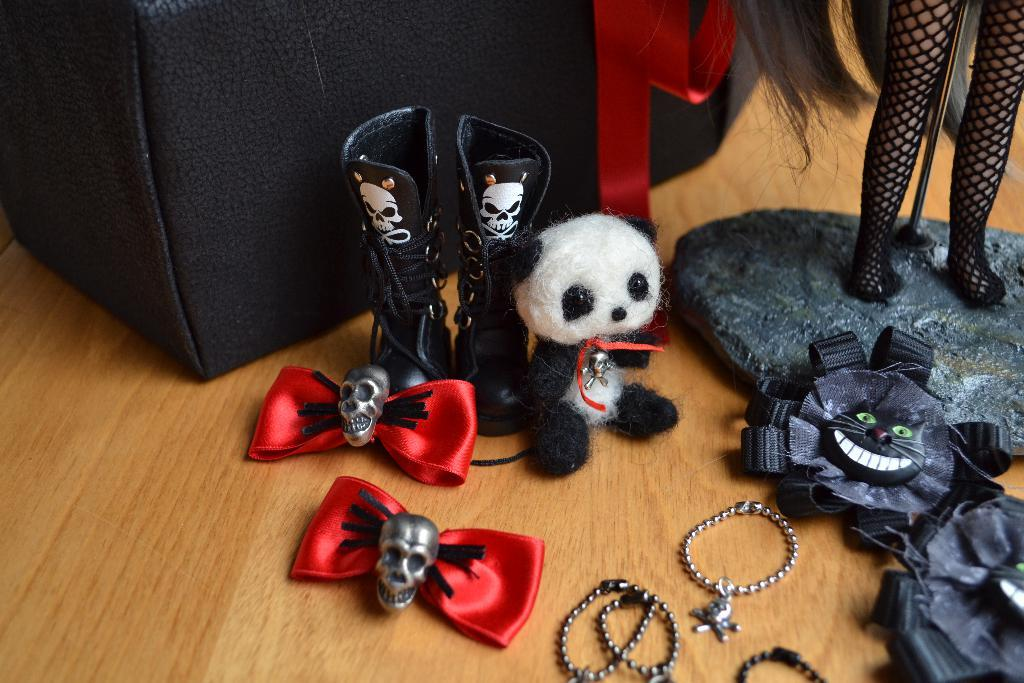What objects are on the floor in the image? There are toys, clothes, chains, and a black color box on the floor. Can you describe the type of toys on the floor? The provided facts do not specify the type of toys on the floor. What is the color of the box on the floor? The box on the floor is black. What else can be seen on the floor besides the box? Clothes and chains are also visible on the floor. Can you see any veins in the image? There are no veins visible in the image, as it features objects on the floor and not any living organisms. What type of banana can be seen in the image? There is no banana present in the image. 